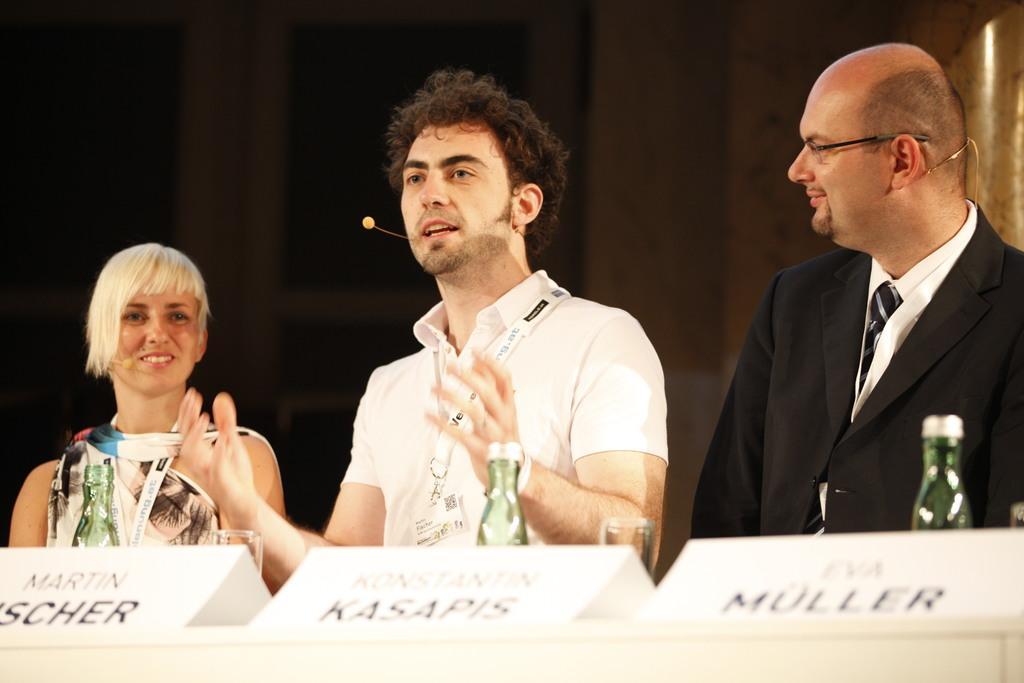Can you describe this image briefly? In the center of the image we can see three persons are in different costumes and they are smiling. In front of them, there is a platform. On the platform, we can see bottles, boards with some text and some objects. And we can see the dark background. 